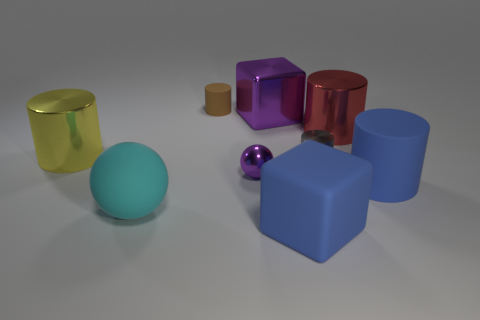What size is the rubber thing behind the large cylinder that is on the left side of the block that is in front of the metallic sphere?
Your answer should be compact. Small. How big is the purple metallic object in front of the large yellow metal cylinder?
Your response must be concise. Small. There is a large red thing that is the same material as the yellow thing; what shape is it?
Make the answer very short. Cylinder. Does the block in front of the blue rubber cylinder have the same material as the tiny gray cylinder?
Provide a short and direct response. No. How many other things are there of the same material as the big red cylinder?
Provide a short and direct response. 4. What number of things are big rubber objects right of the gray metal cylinder or large objects behind the matte block?
Provide a succinct answer. 5. Do the blue matte thing that is in front of the blue matte cylinder and the tiny metallic object that is right of the metal ball have the same shape?
Keep it short and to the point. No. The yellow shiny object that is the same size as the blue cube is what shape?
Provide a short and direct response. Cylinder. What number of rubber things are purple balls or big purple objects?
Your answer should be very brief. 0. Are the small thing that is behind the small gray metallic cylinder and the tiny thing that is on the right side of the purple metallic block made of the same material?
Provide a short and direct response. No. 